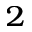<formula> <loc_0><loc_0><loc_500><loc_500>_ { 2 }</formula> 